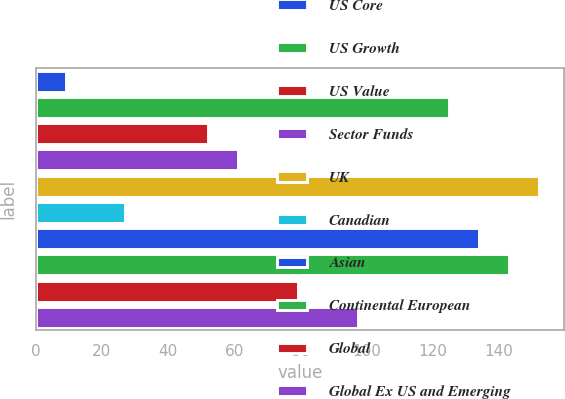<chart> <loc_0><loc_0><loc_500><loc_500><bar_chart><fcel>US Core<fcel>US Growth<fcel>US Value<fcel>Sector Funds<fcel>UK<fcel>Canadian<fcel>Asian<fcel>Continental European<fcel>Global<fcel>Global Ex US and Emerging<nl><fcel>9<fcel>124.8<fcel>52<fcel>61.1<fcel>152.1<fcel>27<fcel>133.9<fcel>143<fcel>79.3<fcel>97.5<nl></chart> 